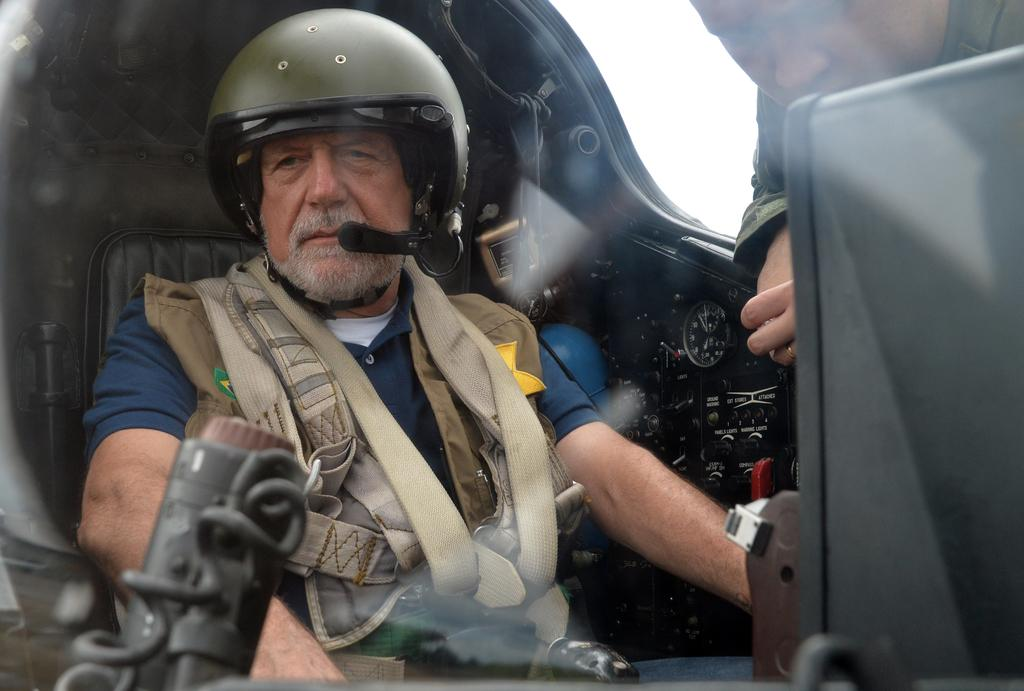What is the person in the image wearing? The person in the image is wearing a jacket and helmet. Where is the person sitting in the image? The person is sitting inside an airplane. Can you describe the other person in the image? There is another person on the right side of the image. What is the argument about between the two men in the image? There are no men present in the image, and no argument is taking place. 